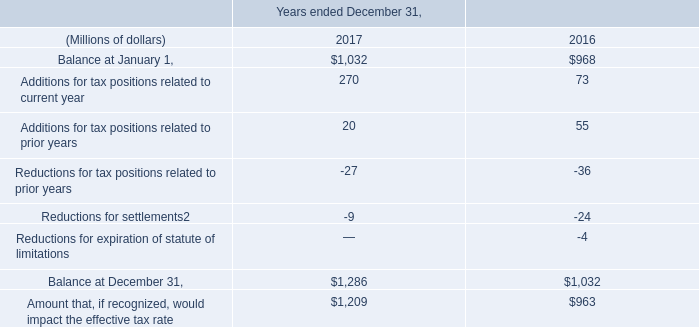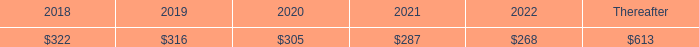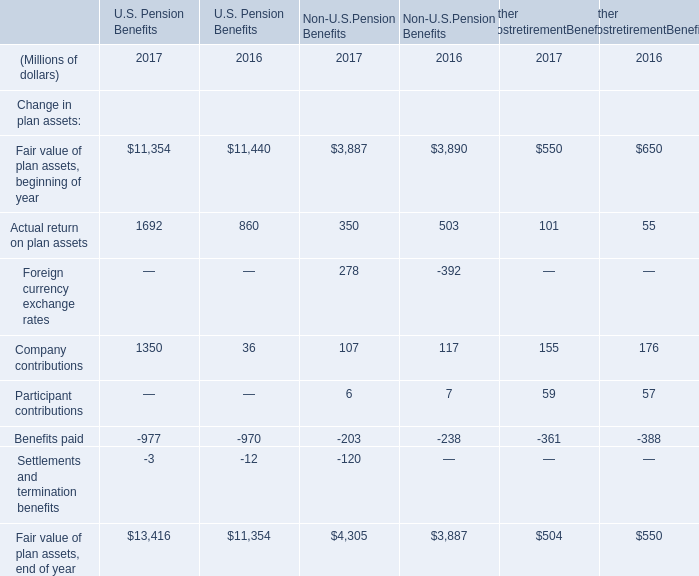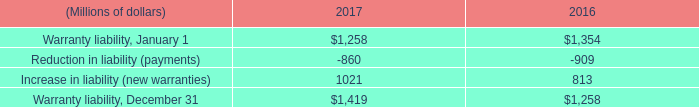What was the average of Actual return on plan assets for U.S. Pension Benefits, Non-U.S.Pension Benefits, and Other PostretirementBenefits ? (in million) 
Computations: ((((((1692 + 860) + 350) + 503) + 101) + 55) / 3)
Answer: 1187.0. 